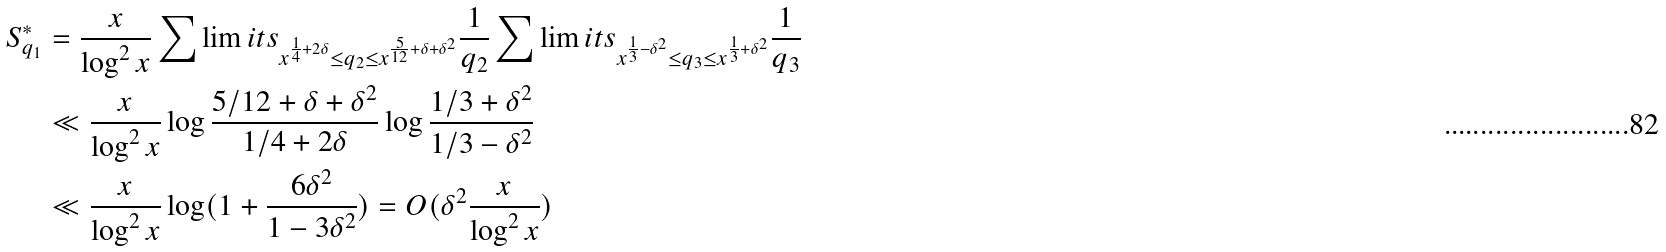<formula> <loc_0><loc_0><loc_500><loc_500>S ^ { * } _ { q _ { 1 } } & = \frac { x } { \log ^ { 2 } x } \sum \lim i t s _ { x ^ { \frac { 1 } { 4 } + 2 \delta } \leq q _ { 2 } \leq x ^ { \frac { 5 } { 1 2 } + \delta + \delta ^ { 2 } } } \frac { 1 } { q _ { 2 } } \sum \lim i t s _ { x ^ { \frac { 1 } { 3 } - \delta ^ { 2 } } \leq q _ { 3 } \leq x ^ { \frac { 1 } { 3 } + \delta ^ { 2 } } } \frac { 1 } { q _ { 3 } } \\ & \ll \frac { x } { \log ^ { 2 } x } \log \frac { 5 / 1 2 + \delta + \delta ^ { 2 } } { 1 / 4 + 2 \delta } \log \frac { 1 / 3 + \delta ^ { 2 } } { 1 / 3 - \delta ^ { 2 } } \\ & \ll \frac { x } { \log ^ { 2 } x } \log ( 1 + \frac { 6 \delta ^ { 2 } } { 1 - 3 \delta ^ { 2 } } ) = O ( \delta ^ { 2 } \frac { x } { \log ^ { 2 } x } )</formula> 